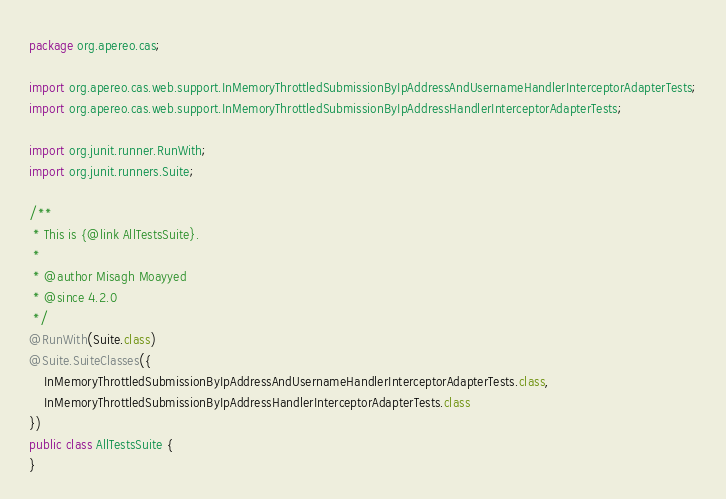Convert code to text. <code><loc_0><loc_0><loc_500><loc_500><_Java_>package org.apereo.cas;

import org.apereo.cas.web.support.InMemoryThrottledSubmissionByIpAddressAndUsernameHandlerInterceptorAdapterTests;
import org.apereo.cas.web.support.InMemoryThrottledSubmissionByIpAddressHandlerInterceptorAdapterTests;

import org.junit.runner.RunWith;
import org.junit.runners.Suite;

/**
 * This is {@link AllTestsSuite}.
 *
 * @author Misagh Moayyed
 * @since 4.2.0
 */
@RunWith(Suite.class)
@Suite.SuiteClasses({
    InMemoryThrottledSubmissionByIpAddressAndUsernameHandlerInterceptorAdapterTests.class,
    InMemoryThrottledSubmissionByIpAddressHandlerInterceptorAdapterTests.class
})
public class AllTestsSuite {
}
</code> 